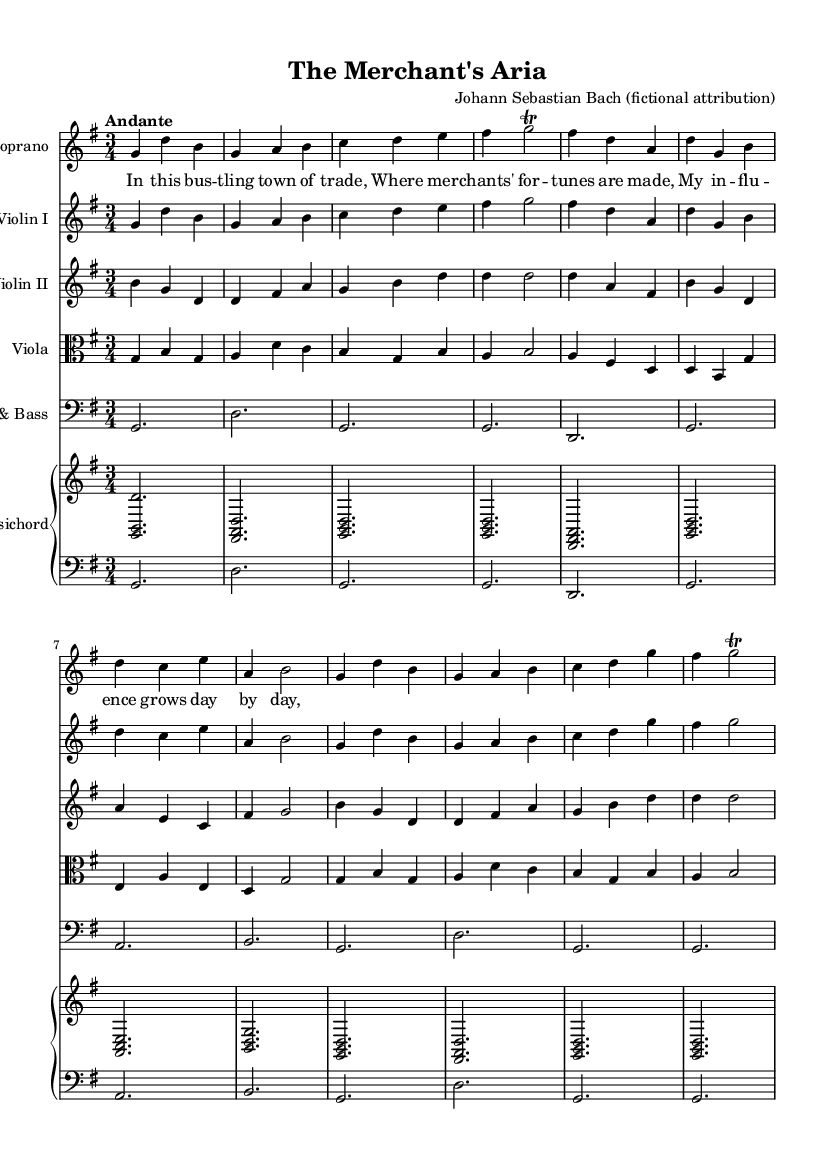What is the key signature of this music? The key signature is G major, which has one sharp (F#). This can be determined from the key signature indicated at the beginning of the score.
Answer: G major What is the time signature of this music? The time signature is 3/4, which indicates three beats per measure and a quarter note gets one beat. This is shown next to the clef at the start of the score.
Answer: 3/4 What is the tempo marking of this piece? The tempo marking is "Andante," which suggests a moderate pace of around 76 to 108 beats per minute. It is typically indicated at the beginning of the score.
Answer: Andante How many measures are in the soprano part? The soprano part contains eight measures, as indicated by the number of distinct groupings of notes between the bar lines.
Answer: 8 What type of musical work is this? This work is a Baroque opera aria, as denoted by the style, instrumentation, and the lyrical content focusing on the life of merchants and civic leaders.
Answer: Baroque opera aria Which instrument plays the harpsichord part? The harpsichord part is played as indicated in the "PianoStaff" section, showing it is part of the continuo group typical of Baroque music.
Answer: Harpsichord What kind of embellishment is indicated in the music? The music includes trills, as shown by the notation but specifically indicated in the soprano part with the "trill" marking next to the note.
Answer: Trill 